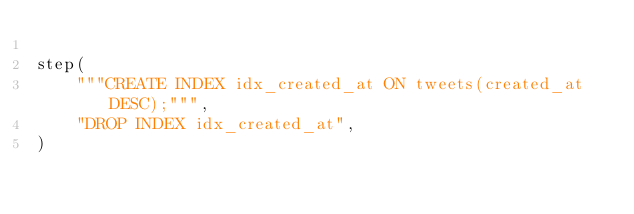<code> <loc_0><loc_0><loc_500><loc_500><_Python_>
step(
    """CREATE INDEX idx_created_at ON tweets(created_at DESC);""",
    "DROP INDEX idx_created_at",
)
</code> 